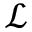<formula> <loc_0><loc_0><loc_500><loc_500>\mathcal { L }</formula> 